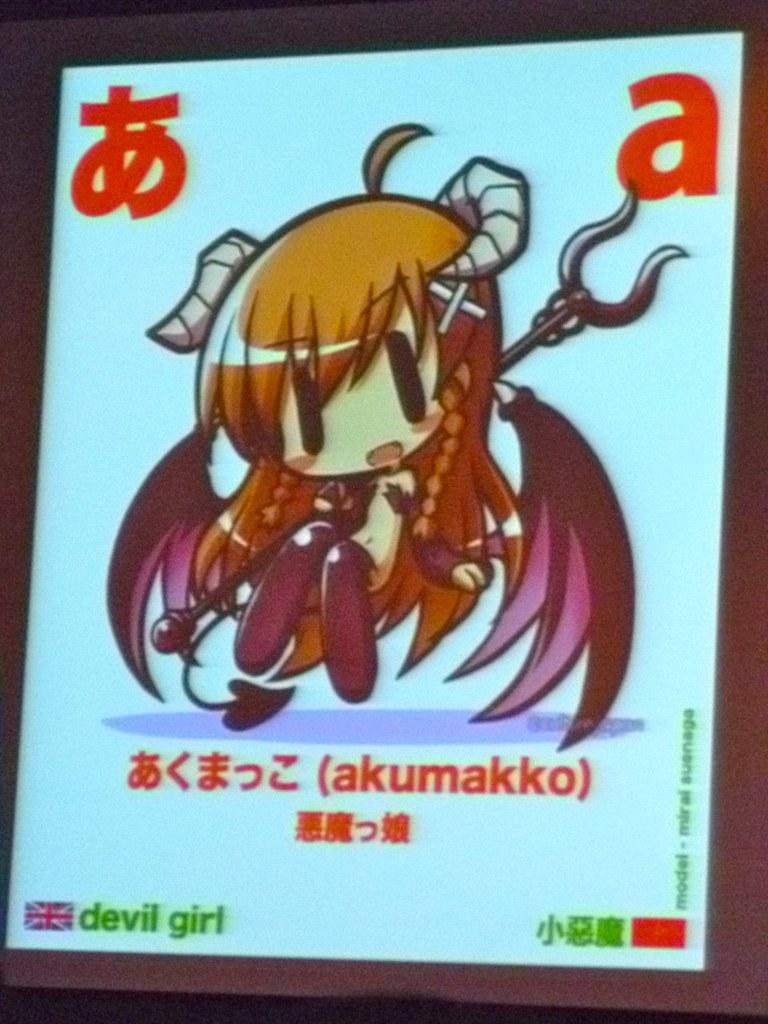What is the word after devil?
Provide a short and direct response. Girl. What letter can be seen on the very top right?
Offer a terse response. A. 